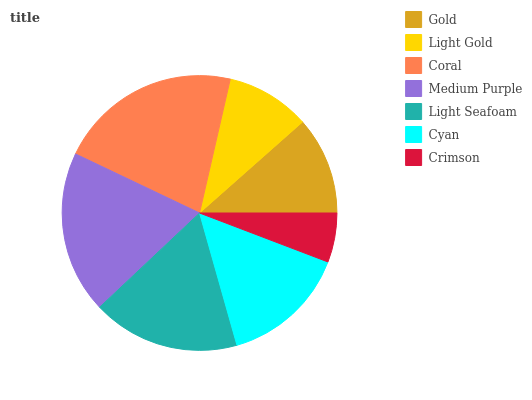Is Crimson the minimum?
Answer yes or no. Yes. Is Coral the maximum?
Answer yes or no. Yes. Is Light Gold the minimum?
Answer yes or no. No. Is Light Gold the maximum?
Answer yes or no. No. Is Gold greater than Light Gold?
Answer yes or no. Yes. Is Light Gold less than Gold?
Answer yes or no. Yes. Is Light Gold greater than Gold?
Answer yes or no. No. Is Gold less than Light Gold?
Answer yes or no. No. Is Cyan the high median?
Answer yes or no. Yes. Is Cyan the low median?
Answer yes or no. Yes. Is Light Seafoam the high median?
Answer yes or no. No. Is Gold the low median?
Answer yes or no. No. 